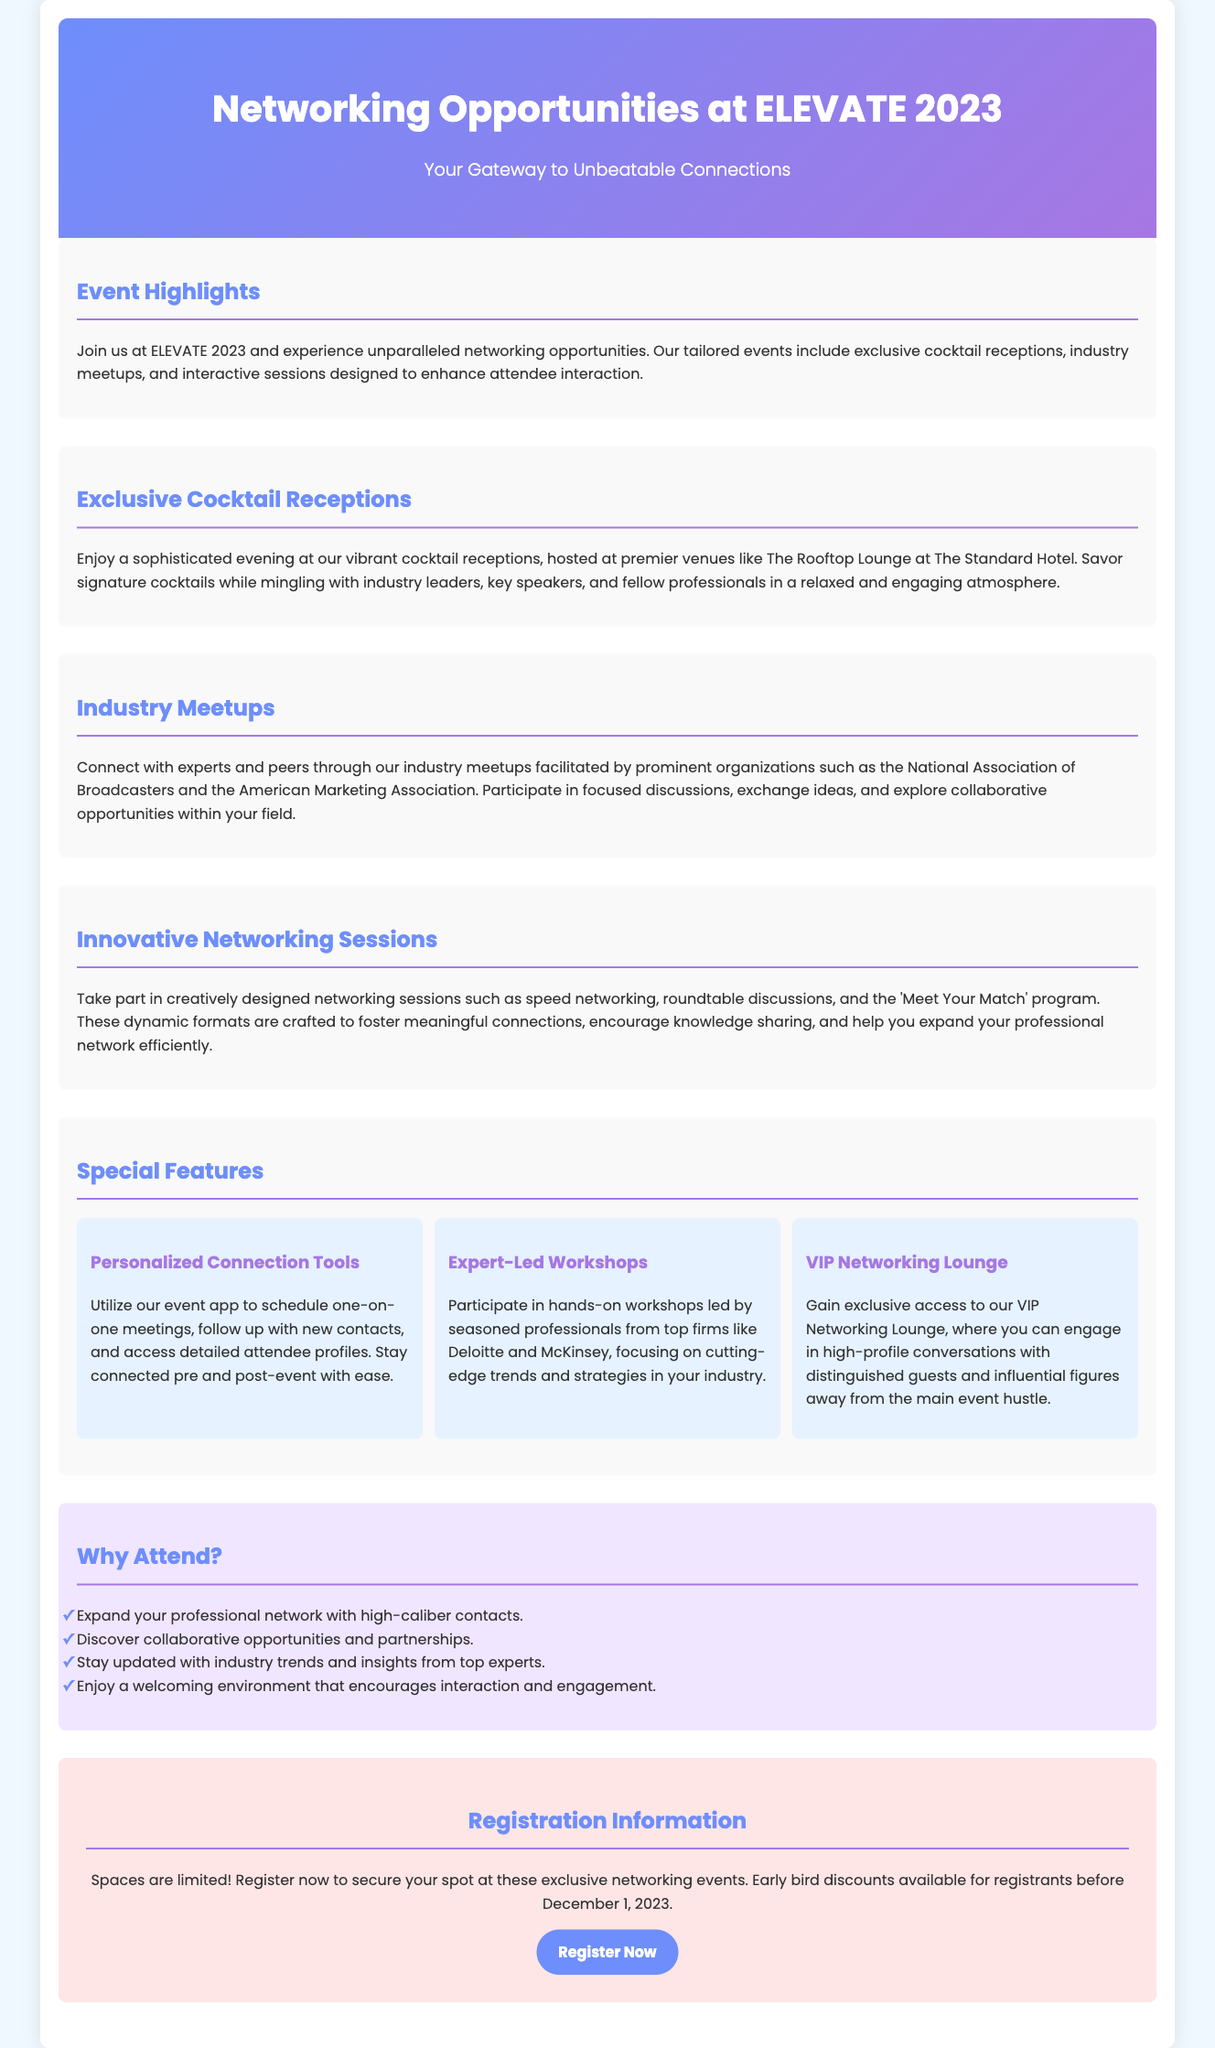What is the title of the event? The title of the event is prominently displayed at the top of the brochure.
Answer: Networking Opportunities at ELEVATE 2023 What is the date for early bird registration discounts? The document specifies that early bird discounts are available until December 1, 2023.
Answer: December 1, 2023 What type of sessions are included in the networking opportunities? The document lists several types of sessions that enhance networking, including 'speed networking'.
Answer: speed networking Who will host the cocktail receptions? The document mentions a specific venue for the cocktail receptions.
Answer: The Rooftop Lounge at The Standard Hotel What organizations are mentioned for industry meetups? The document includes two prominent organizations that will facilitate meetups.
Answer: National Association of Broadcasters, American Marketing Association What is a feature of the VIP Networking Lounge? The document highlights a specific benefit of the VIP Networking Lounge.
Answer: engage in high-profile conversations What is one reason to attend the event? The document cites various benefits to attending, including expanding your professional network.
Answer: Expand your professional network What are the personalized connection tools used for? The document describes a specific function of the event app.
Answer: schedule one-on-one meetings What is showcased in the Expert-Led Workshops? The document details the focus of the workshops conducted by professionals.
Answer: cutting-edge trends and strategies 